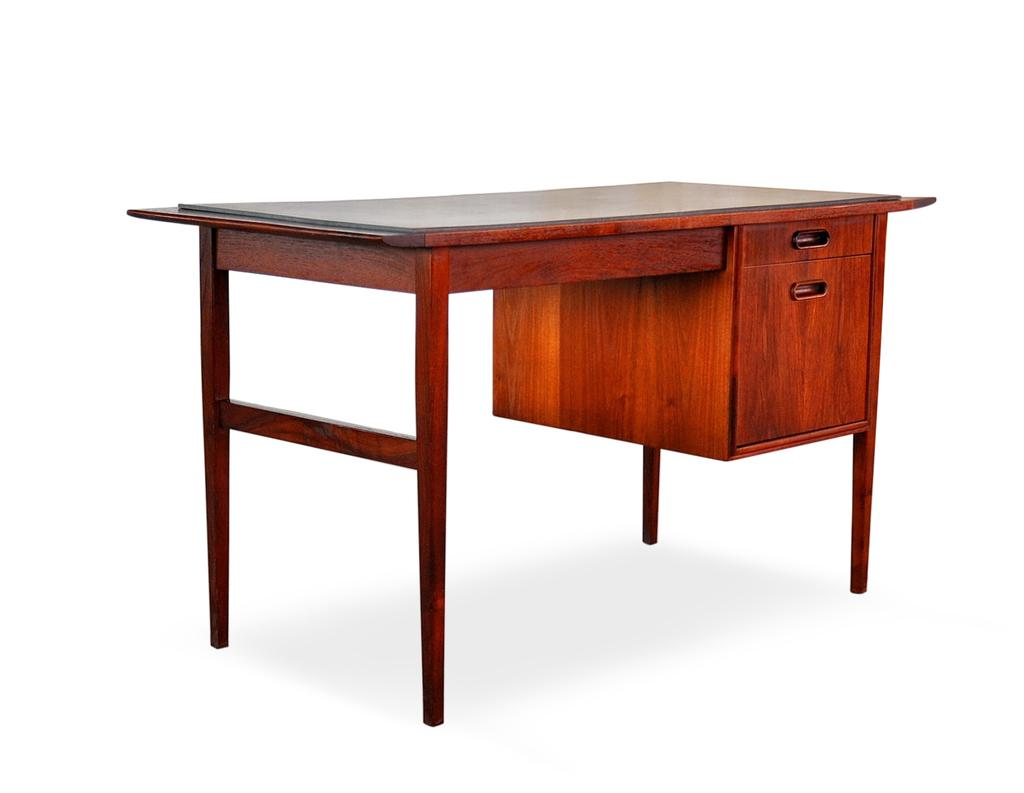What type of furniture is present in the image? There is a table in the image. What color is the table? The table is brown in color. What can be seen in the background of the image? The background of the image is white. Is there an owl sitting on the desk in the image? There is no desk or owl present in the image; it only features a brown table with a white background. 